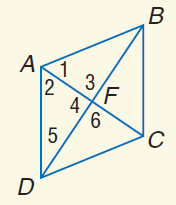Question: Use rhombus A B C D with m \angle 1 = 2 x + 20, m \angle 2 = 5 x - 4, A C = 15, and m \angle 3 = y^ { 2 } + 26. Find A F.
Choices:
A. 2.5
B. 5
C. 7.5
D. 10
Answer with the letter. Answer: C Question: Use rhombus A B C D with m \angle 1 = 2 x + 20, m \angle 2 = 5 x - 4, A C = 15, and m \angle 3 = y^ { 2 } + 26. Find x.
Choices:
A. 2
B. 4
C. 6
D. 8
Answer with the letter. Answer: D 